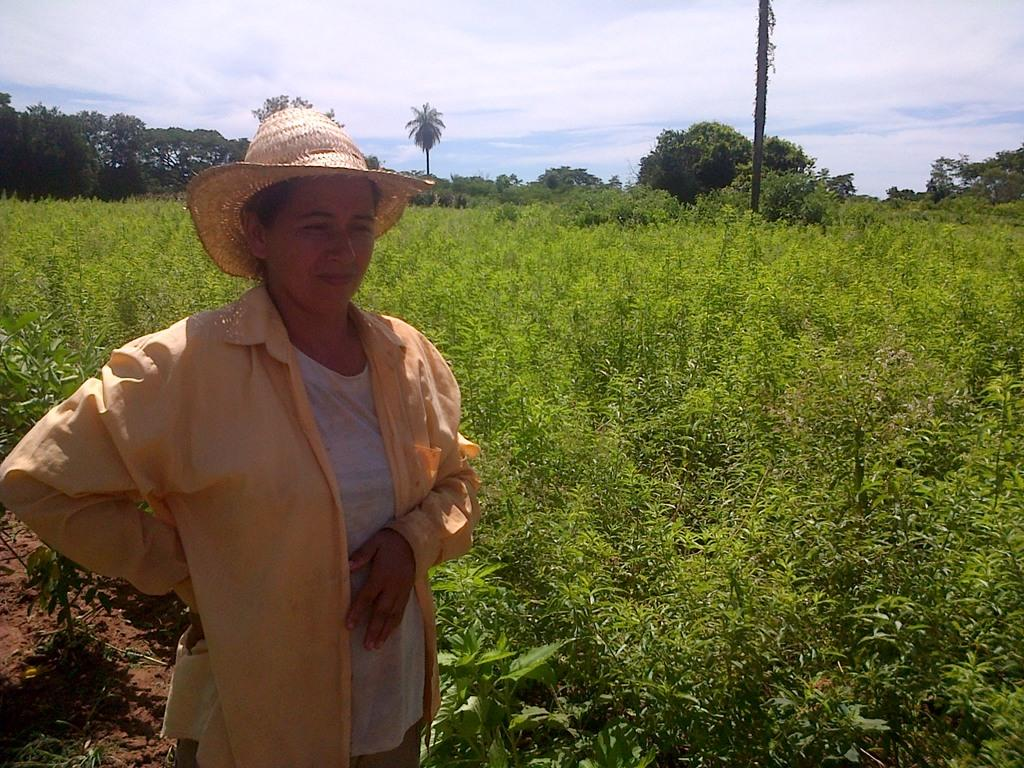Who is present in the image? There is a woman in the image. What is the woman wearing on her head? The woman is wearing a hat. What is the woman's position in relation to the ground? The woman is standing on the ground. What type of vegetation can be seen in the image? There is a group of plants and a group of trees in the image. What part of a tree is visible in the image? The bark of a tree is visible in the image. What is visible in the background of the image? The sky is visible in the image, and it appears to be cloudy. What type of quilt is being used to cover the trees in the image? There is no quilt present in the image; it features a woman, plants, trees, and a cloudy sky. 